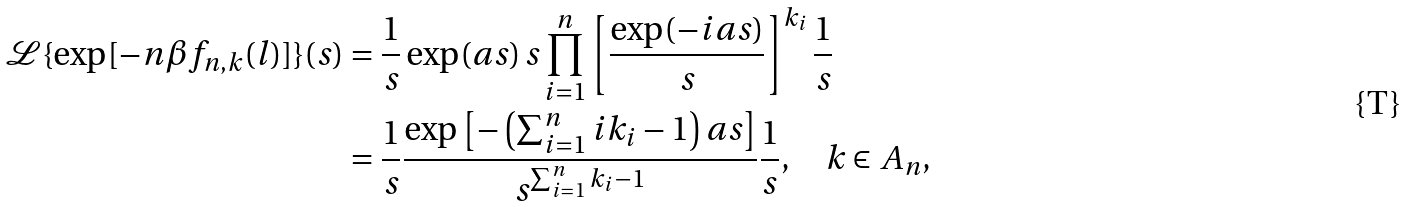Convert formula to latex. <formula><loc_0><loc_0><loc_500><loc_500>\mathcal { L } \{ \exp [ - n \beta f _ { n , k } ( l ) ] \} ( s ) & = \frac { 1 } { s } \exp ( a s ) \, s \prod _ { i = 1 } ^ { n } \left [ \frac { \exp ( - i a s ) } { s } \right ] ^ { k _ { i } } \frac { 1 } { s } \\ & = \frac { 1 } { s } \frac { \exp \left [ - \left ( \sum _ { i = 1 } ^ { n } i k _ { i } - 1 \right ) a s \right ] } { s ^ { \sum _ { i = 1 } ^ { n } k _ { i } - 1 } } \frac { 1 } { s } , \quad k \in A _ { n } ,</formula> 